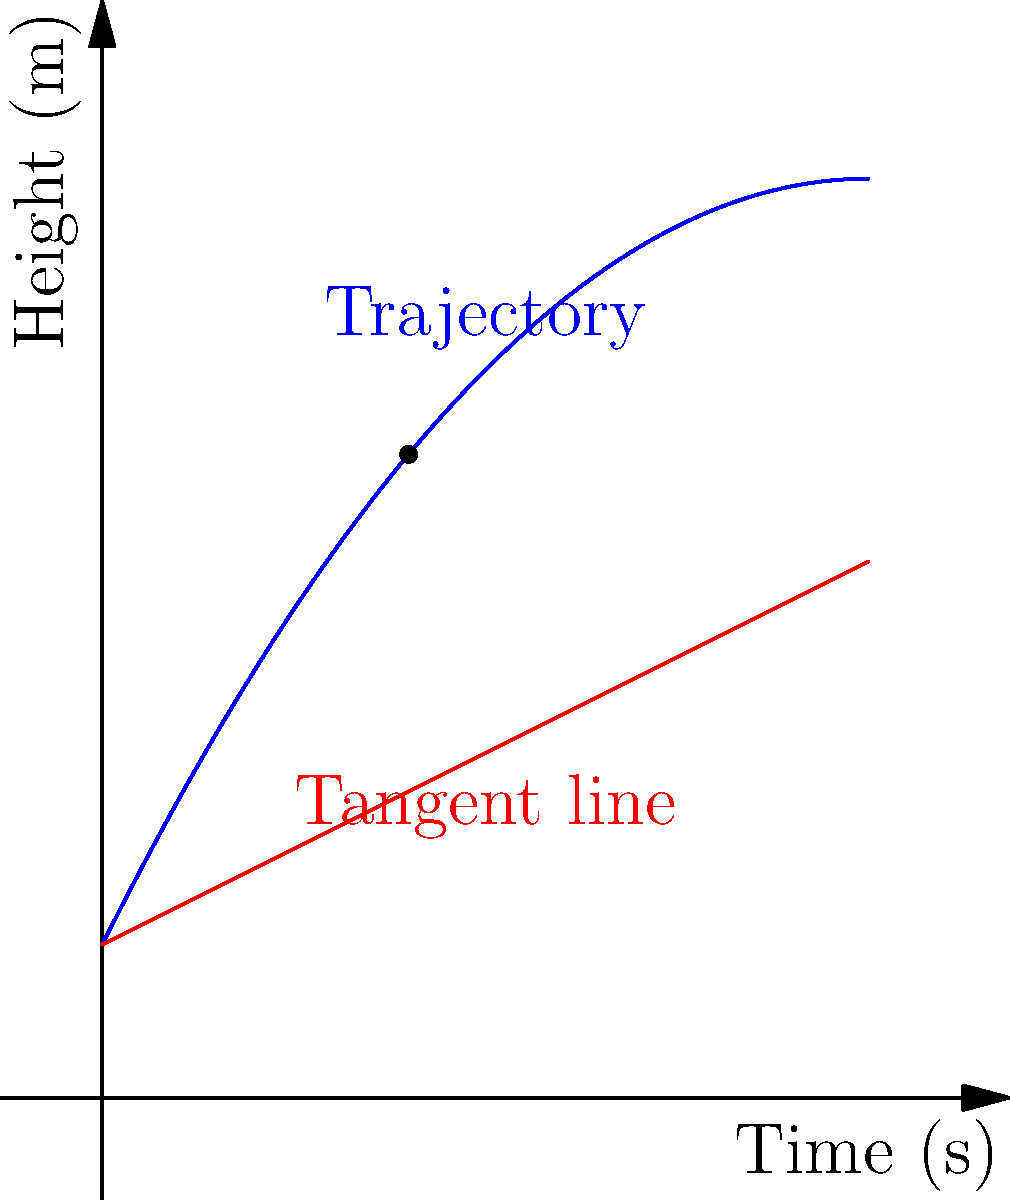As a graphics designer, you're creating a visual representation of a basketball's trajectory during a slam dunk. The path of the ball can be modeled by the function $h(t) = -0.2t^2 + 2t + 1$, where $h$ is the height in meters and $t$ is the time in seconds. What is the instantaneous rate of change of the ball's height at $t = 2$ seconds? To find the instantaneous rate of change at $t = 2$ seconds, we need to calculate the derivative of the function $h(t)$ and then evaluate it at $t = 2$. Here's the step-by-step process:

1) The given function is $h(t) = -0.2t^2 + 2t + 1$

2) To find the derivative, we use the power rule and constant rule:
   $h'(t) = -0.2 \cdot 2t + 2 + 0$
   $h'(t) = -0.4t + 2$

3) Now, we evaluate $h'(t)$ at $t = 2$:
   $h'(2) = -0.4(2) + 2$
   $h'(2) = -0.8 + 2$
   $h'(2) = 1.2$

4) The instantaneous rate of change is the value of the derivative at the given point.

5) In the context of the problem, this means the ball's height is changing at a rate of 1.2 meters per second at $t = 2$ seconds.

The blue curve in the graph represents the trajectory of the ball, while the red line represents the tangent line at $t = 2$ seconds, whose slope is the instantaneous rate of change we calculated.
Answer: 1.2 m/s 